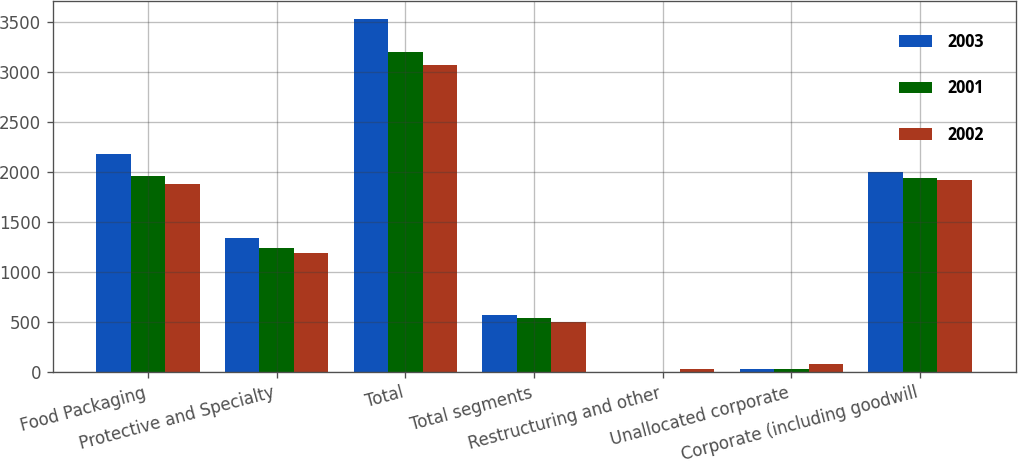Convert chart. <chart><loc_0><loc_0><loc_500><loc_500><stacked_bar_chart><ecel><fcel>Food Packaging<fcel>Protective and Specialty<fcel>Total<fcel>Total segments<fcel>Restructuring and other<fcel>Unallocated corporate<fcel>Corporate (including goodwill<nl><fcel>2003<fcel>2185.7<fcel>1346.2<fcel>3531.9<fcel>571.1<fcel>0.5<fcel>32.4<fcel>1996.2<nl><fcel>2001<fcel>1958.1<fcel>1246.2<fcel>3204.3<fcel>544.7<fcel>1.3<fcel>29.6<fcel>1943.5<nl><fcel>2002<fcel>1880.3<fcel>1187.2<fcel>3067.5<fcel>498.7<fcel>32.8<fcel>78.5<fcel>1919.6<nl></chart> 